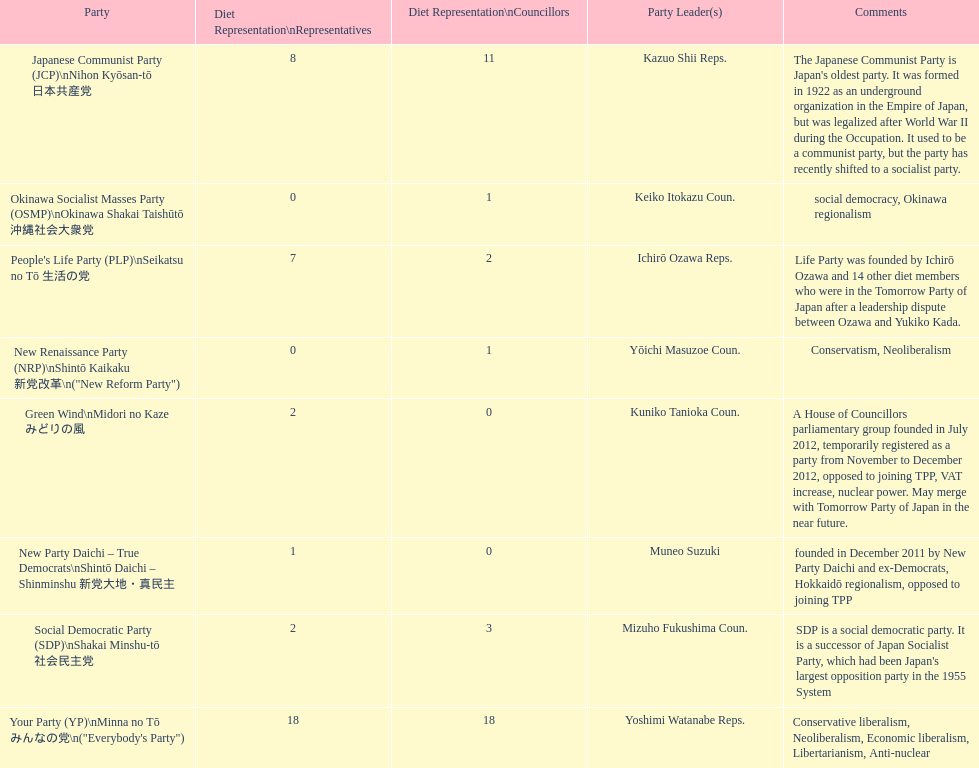How many representatives come from the green wind party? 2. 